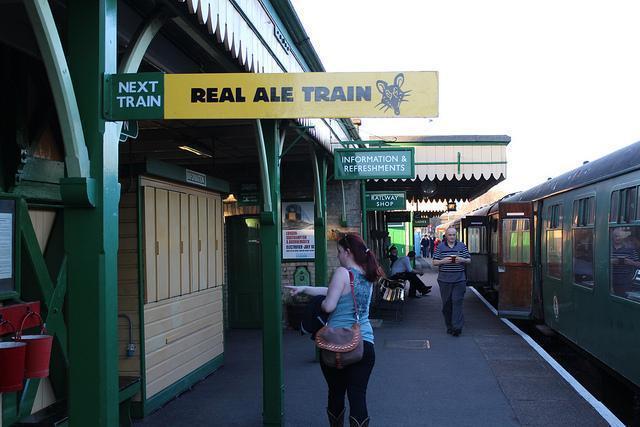How many people are in the picture?
Give a very brief answer. 2. 